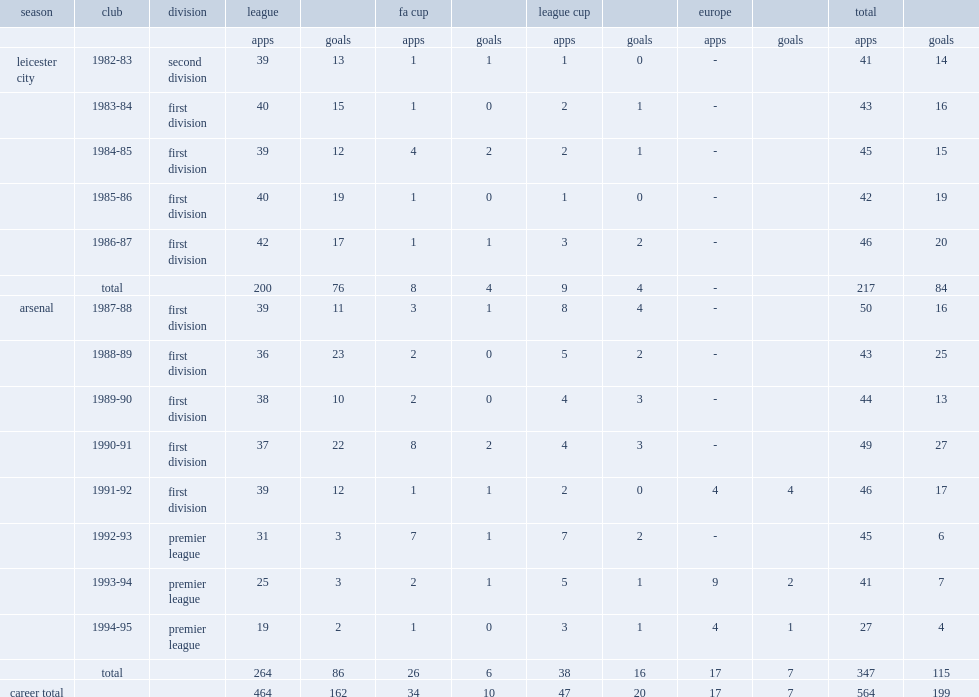How many goals did smith score for arsenal totally? 115.0. Parse the table in full. {'header': ['season', 'club', 'division', 'league', '', 'fa cup', '', 'league cup', '', 'europe', '', 'total', ''], 'rows': [['', '', '', 'apps', 'goals', 'apps', 'goals', 'apps', 'goals', 'apps', 'goals', 'apps', 'goals'], ['leicester city', '1982-83', 'second division', '39', '13', '1', '1', '1', '0', '-', '', '41', '14'], ['', '1983-84', 'first division', '40', '15', '1', '0', '2', '1', '-', '', '43', '16'], ['', '1984-85', 'first division', '39', '12', '4', '2', '2', '1', '-', '', '45', '15'], ['', '1985-86', 'first division', '40', '19', '1', '0', '1', '0', '-', '', '42', '19'], ['', '1986-87', 'first division', '42', '17', '1', '1', '3', '2', '-', '', '46', '20'], ['', 'total', '', '200', '76', '8', '4', '9', '4', '-', '', '217', '84'], ['arsenal', '1987-88', 'first division', '39', '11', '3', '1', '8', '4', '-', '', '50', '16'], ['', '1988-89', 'first division', '36', '23', '2', '0', '5', '2', '-', '', '43', '25'], ['', '1989-90', 'first division', '38', '10', '2', '0', '4', '3', '-', '', '44', '13'], ['', '1990-91', 'first division', '37', '22', '8', '2', '4', '3', '-', '', '49', '27'], ['', '1991-92', 'first division', '39', '12', '1', '1', '2', '0', '4', '4', '46', '17'], ['', '1992-93', 'premier league', '31', '3', '7', '1', '7', '2', '-', '', '45', '6'], ['', '1993-94', 'premier league', '25', '3', '2', '1', '5', '1', '9', '2', '41', '7'], ['', '1994-95', 'premier league', '19', '2', '1', '0', '3', '1', '4', '1', '27', '4'], ['', 'total', '', '264', '86', '26', '6', '38', '16', '17', '7', '347', '115'], ['career total', '', '', '464', '162', '34', '10', '47', '20', '17', '7', '564', '199']]} 